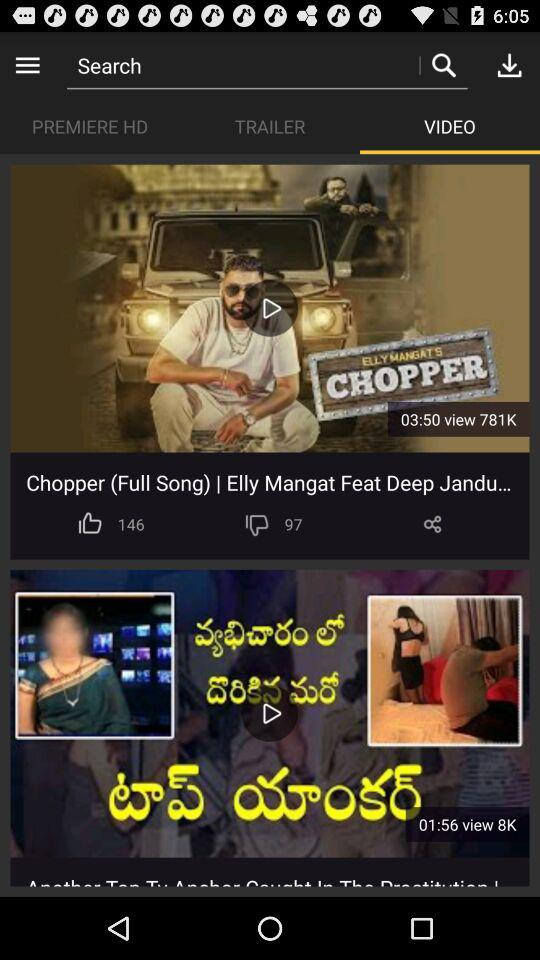How many dislikes did "Chopper (Full Song)" get? "Chopper (Full Song)" got 97 dislikes. 